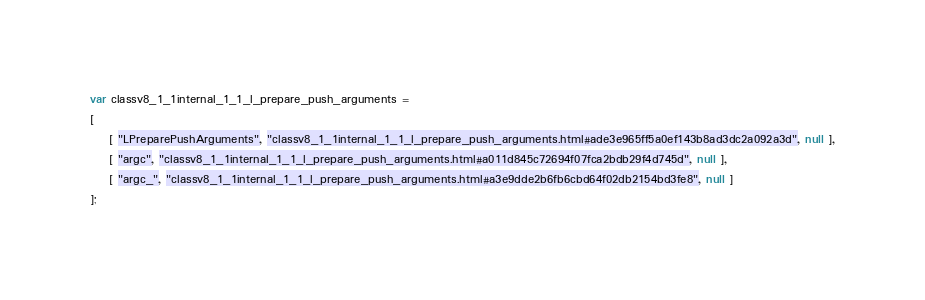<code> <loc_0><loc_0><loc_500><loc_500><_JavaScript_>var classv8_1_1internal_1_1_l_prepare_push_arguments =
[
    [ "LPreparePushArguments", "classv8_1_1internal_1_1_l_prepare_push_arguments.html#ade3e965ff5a0ef143b8ad3dc2a092a3d", null ],
    [ "argc", "classv8_1_1internal_1_1_l_prepare_push_arguments.html#a011d845c72694f07fca2bdb29f4d745d", null ],
    [ "argc_", "classv8_1_1internal_1_1_l_prepare_push_arguments.html#a3e9dde2b6fb6cbd64f02db2154bd3fe8", null ]
];</code> 